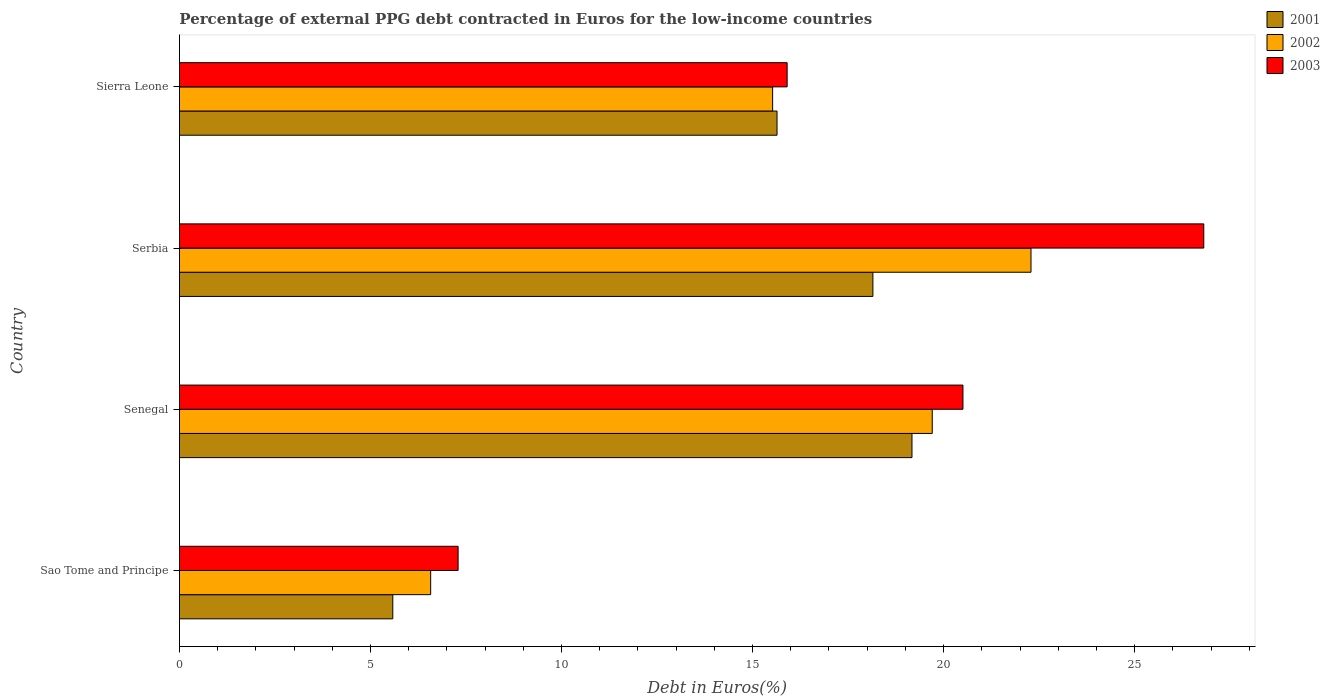How many groups of bars are there?
Give a very brief answer. 4. Are the number of bars on each tick of the Y-axis equal?
Make the answer very short. Yes. How many bars are there on the 2nd tick from the top?
Provide a short and direct response. 3. What is the label of the 2nd group of bars from the top?
Provide a short and direct response. Serbia. What is the percentage of external PPG debt contracted in Euros in 2001 in Senegal?
Your answer should be very brief. 19.17. Across all countries, what is the maximum percentage of external PPG debt contracted in Euros in 2001?
Provide a succinct answer. 19.17. Across all countries, what is the minimum percentage of external PPG debt contracted in Euros in 2001?
Offer a terse response. 5.58. In which country was the percentage of external PPG debt contracted in Euros in 2001 maximum?
Provide a short and direct response. Senegal. In which country was the percentage of external PPG debt contracted in Euros in 2003 minimum?
Provide a succinct answer. Sao Tome and Principe. What is the total percentage of external PPG debt contracted in Euros in 2001 in the graph?
Offer a very short reply. 58.55. What is the difference between the percentage of external PPG debt contracted in Euros in 2001 in Senegal and that in Serbia?
Your answer should be very brief. 1.02. What is the difference between the percentage of external PPG debt contracted in Euros in 2001 in Sierra Leone and the percentage of external PPG debt contracted in Euros in 2003 in Serbia?
Your response must be concise. -11.17. What is the average percentage of external PPG debt contracted in Euros in 2003 per country?
Provide a succinct answer. 17.63. What is the difference between the percentage of external PPG debt contracted in Euros in 2003 and percentage of external PPG debt contracted in Euros in 2001 in Sierra Leone?
Keep it short and to the point. 0.26. What is the ratio of the percentage of external PPG debt contracted in Euros in 2001 in Sao Tome and Principe to that in Serbia?
Your answer should be compact. 0.31. Is the percentage of external PPG debt contracted in Euros in 2002 in Sao Tome and Principe less than that in Serbia?
Keep it short and to the point. Yes. What is the difference between the highest and the second highest percentage of external PPG debt contracted in Euros in 2003?
Make the answer very short. 6.3. What is the difference between the highest and the lowest percentage of external PPG debt contracted in Euros in 2002?
Offer a terse response. 15.71. In how many countries, is the percentage of external PPG debt contracted in Euros in 2002 greater than the average percentage of external PPG debt contracted in Euros in 2002 taken over all countries?
Your answer should be compact. 2. Is the sum of the percentage of external PPG debt contracted in Euros in 2003 in Sao Tome and Principe and Serbia greater than the maximum percentage of external PPG debt contracted in Euros in 2002 across all countries?
Keep it short and to the point. Yes. What does the 2nd bar from the bottom in Sierra Leone represents?
Ensure brevity in your answer.  2002. Is it the case that in every country, the sum of the percentage of external PPG debt contracted in Euros in 2001 and percentage of external PPG debt contracted in Euros in 2002 is greater than the percentage of external PPG debt contracted in Euros in 2003?
Provide a succinct answer. Yes. Are all the bars in the graph horizontal?
Offer a very short reply. Yes. How many countries are there in the graph?
Make the answer very short. 4. What is the difference between two consecutive major ticks on the X-axis?
Offer a terse response. 5. Are the values on the major ticks of X-axis written in scientific E-notation?
Offer a very short reply. No. Does the graph contain any zero values?
Offer a very short reply. No. Does the graph contain grids?
Give a very brief answer. No. How many legend labels are there?
Provide a succinct answer. 3. What is the title of the graph?
Keep it short and to the point. Percentage of external PPG debt contracted in Euros for the low-income countries. What is the label or title of the X-axis?
Keep it short and to the point. Debt in Euros(%). What is the label or title of the Y-axis?
Ensure brevity in your answer.  Country. What is the Debt in Euros(%) of 2001 in Sao Tome and Principe?
Keep it short and to the point. 5.58. What is the Debt in Euros(%) in 2002 in Sao Tome and Principe?
Your answer should be very brief. 6.58. What is the Debt in Euros(%) in 2003 in Sao Tome and Principe?
Make the answer very short. 7.29. What is the Debt in Euros(%) of 2001 in Senegal?
Give a very brief answer. 19.17. What is the Debt in Euros(%) in 2002 in Senegal?
Provide a succinct answer. 19.7. What is the Debt in Euros(%) in 2003 in Senegal?
Your answer should be very brief. 20.51. What is the Debt in Euros(%) in 2001 in Serbia?
Make the answer very short. 18.15. What is the Debt in Euros(%) of 2002 in Serbia?
Ensure brevity in your answer.  22.29. What is the Debt in Euros(%) of 2003 in Serbia?
Your answer should be compact. 26.81. What is the Debt in Euros(%) of 2001 in Sierra Leone?
Provide a succinct answer. 15.64. What is the Debt in Euros(%) of 2002 in Sierra Leone?
Provide a succinct answer. 15.53. What is the Debt in Euros(%) in 2003 in Sierra Leone?
Keep it short and to the point. 15.91. Across all countries, what is the maximum Debt in Euros(%) of 2001?
Your answer should be very brief. 19.17. Across all countries, what is the maximum Debt in Euros(%) of 2002?
Provide a short and direct response. 22.29. Across all countries, what is the maximum Debt in Euros(%) of 2003?
Offer a terse response. 26.81. Across all countries, what is the minimum Debt in Euros(%) of 2001?
Make the answer very short. 5.58. Across all countries, what is the minimum Debt in Euros(%) of 2002?
Ensure brevity in your answer.  6.58. Across all countries, what is the minimum Debt in Euros(%) of 2003?
Provide a succinct answer. 7.29. What is the total Debt in Euros(%) in 2001 in the graph?
Give a very brief answer. 58.55. What is the total Debt in Euros(%) of 2002 in the graph?
Your answer should be very brief. 64.09. What is the total Debt in Euros(%) of 2003 in the graph?
Offer a terse response. 70.51. What is the difference between the Debt in Euros(%) in 2001 in Sao Tome and Principe and that in Senegal?
Make the answer very short. -13.59. What is the difference between the Debt in Euros(%) of 2002 in Sao Tome and Principe and that in Senegal?
Offer a terse response. -13.13. What is the difference between the Debt in Euros(%) in 2003 in Sao Tome and Principe and that in Senegal?
Your answer should be compact. -13.21. What is the difference between the Debt in Euros(%) in 2001 in Sao Tome and Principe and that in Serbia?
Offer a terse response. -12.57. What is the difference between the Debt in Euros(%) of 2002 in Sao Tome and Principe and that in Serbia?
Provide a succinct answer. -15.71. What is the difference between the Debt in Euros(%) in 2003 in Sao Tome and Principe and that in Serbia?
Provide a short and direct response. -19.52. What is the difference between the Debt in Euros(%) of 2001 in Sao Tome and Principe and that in Sierra Leone?
Your response must be concise. -10.06. What is the difference between the Debt in Euros(%) in 2002 in Sao Tome and Principe and that in Sierra Leone?
Offer a terse response. -8.95. What is the difference between the Debt in Euros(%) of 2003 in Sao Tome and Principe and that in Sierra Leone?
Give a very brief answer. -8.61. What is the difference between the Debt in Euros(%) in 2001 in Senegal and that in Serbia?
Your answer should be compact. 1.02. What is the difference between the Debt in Euros(%) of 2002 in Senegal and that in Serbia?
Offer a very short reply. -2.58. What is the difference between the Debt in Euros(%) in 2003 in Senegal and that in Serbia?
Offer a terse response. -6.3. What is the difference between the Debt in Euros(%) in 2001 in Senegal and that in Sierra Leone?
Ensure brevity in your answer.  3.53. What is the difference between the Debt in Euros(%) of 2002 in Senegal and that in Sierra Leone?
Your response must be concise. 4.18. What is the difference between the Debt in Euros(%) of 2003 in Senegal and that in Sierra Leone?
Provide a short and direct response. 4.6. What is the difference between the Debt in Euros(%) of 2001 in Serbia and that in Sierra Leone?
Ensure brevity in your answer.  2.51. What is the difference between the Debt in Euros(%) in 2002 in Serbia and that in Sierra Leone?
Offer a terse response. 6.76. What is the difference between the Debt in Euros(%) of 2003 in Serbia and that in Sierra Leone?
Keep it short and to the point. 10.9. What is the difference between the Debt in Euros(%) of 2001 in Sao Tome and Principe and the Debt in Euros(%) of 2002 in Senegal?
Provide a succinct answer. -14.12. What is the difference between the Debt in Euros(%) of 2001 in Sao Tome and Principe and the Debt in Euros(%) of 2003 in Senegal?
Provide a short and direct response. -14.92. What is the difference between the Debt in Euros(%) in 2002 in Sao Tome and Principe and the Debt in Euros(%) in 2003 in Senegal?
Give a very brief answer. -13.93. What is the difference between the Debt in Euros(%) in 2001 in Sao Tome and Principe and the Debt in Euros(%) in 2002 in Serbia?
Keep it short and to the point. -16.7. What is the difference between the Debt in Euros(%) in 2001 in Sao Tome and Principe and the Debt in Euros(%) in 2003 in Serbia?
Offer a terse response. -21.22. What is the difference between the Debt in Euros(%) in 2002 in Sao Tome and Principe and the Debt in Euros(%) in 2003 in Serbia?
Provide a short and direct response. -20.23. What is the difference between the Debt in Euros(%) in 2001 in Sao Tome and Principe and the Debt in Euros(%) in 2002 in Sierra Leone?
Your answer should be compact. -9.94. What is the difference between the Debt in Euros(%) in 2001 in Sao Tome and Principe and the Debt in Euros(%) in 2003 in Sierra Leone?
Provide a short and direct response. -10.32. What is the difference between the Debt in Euros(%) of 2002 in Sao Tome and Principe and the Debt in Euros(%) of 2003 in Sierra Leone?
Provide a succinct answer. -9.33. What is the difference between the Debt in Euros(%) in 2001 in Senegal and the Debt in Euros(%) in 2002 in Serbia?
Offer a terse response. -3.11. What is the difference between the Debt in Euros(%) of 2001 in Senegal and the Debt in Euros(%) of 2003 in Serbia?
Provide a short and direct response. -7.64. What is the difference between the Debt in Euros(%) of 2002 in Senegal and the Debt in Euros(%) of 2003 in Serbia?
Offer a terse response. -7.11. What is the difference between the Debt in Euros(%) of 2001 in Senegal and the Debt in Euros(%) of 2002 in Sierra Leone?
Ensure brevity in your answer.  3.65. What is the difference between the Debt in Euros(%) of 2001 in Senegal and the Debt in Euros(%) of 2003 in Sierra Leone?
Keep it short and to the point. 3.27. What is the difference between the Debt in Euros(%) in 2002 in Senegal and the Debt in Euros(%) in 2003 in Sierra Leone?
Your answer should be very brief. 3.8. What is the difference between the Debt in Euros(%) in 2001 in Serbia and the Debt in Euros(%) in 2002 in Sierra Leone?
Offer a terse response. 2.62. What is the difference between the Debt in Euros(%) of 2001 in Serbia and the Debt in Euros(%) of 2003 in Sierra Leone?
Ensure brevity in your answer.  2.24. What is the difference between the Debt in Euros(%) of 2002 in Serbia and the Debt in Euros(%) of 2003 in Sierra Leone?
Your answer should be very brief. 6.38. What is the average Debt in Euros(%) in 2001 per country?
Make the answer very short. 14.64. What is the average Debt in Euros(%) of 2002 per country?
Make the answer very short. 16.02. What is the average Debt in Euros(%) in 2003 per country?
Offer a terse response. 17.63. What is the difference between the Debt in Euros(%) in 2001 and Debt in Euros(%) in 2002 in Sao Tome and Principe?
Give a very brief answer. -0.99. What is the difference between the Debt in Euros(%) of 2001 and Debt in Euros(%) of 2003 in Sao Tome and Principe?
Provide a short and direct response. -1.71. What is the difference between the Debt in Euros(%) in 2002 and Debt in Euros(%) in 2003 in Sao Tome and Principe?
Offer a terse response. -0.72. What is the difference between the Debt in Euros(%) in 2001 and Debt in Euros(%) in 2002 in Senegal?
Your answer should be very brief. -0.53. What is the difference between the Debt in Euros(%) of 2001 and Debt in Euros(%) of 2003 in Senegal?
Provide a short and direct response. -1.33. What is the difference between the Debt in Euros(%) of 2002 and Debt in Euros(%) of 2003 in Senegal?
Ensure brevity in your answer.  -0.8. What is the difference between the Debt in Euros(%) in 2001 and Debt in Euros(%) in 2002 in Serbia?
Your response must be concise. -4.14. What is the difference between the Debt in Euros(%) of 2001 and Debt in Euros(%) of 2003 in Serbia?
Provide a short and direct response. -8.66. What is the difference between the Debt in Euros(%) of 2002 and Debt in Euros(%) of 2003 in Serbia?
Make the answer very short. -4.52. What is the difference between the Debt in Euros(%) of 2001 and Debt in Euros(%) of 2002 in Sierra Leone?
Make the answer very short. 0.12. What is the difference between the Debt in Euros(%) in 2001 and Debt in Euros(%) in 2003 in Sierra Leone?
Offer a terse response. -0.26. What is the difference between the Debt in Euros(%) in 2002 and Debt in Euros(%) in 2003 in Sierra Leone?
Keep it short and to the point. -0.38. What is the ratio of the Debt in Euros(%) in 2001 in Sao Tome and Principe to that in Senegal?
Ensure brevity in your answer.  0.29. What is the ratio of the Debt in Euros(%) in 2002 in Sao Tome and Principe to that in Senegal?
Give a very brief answer. 0.33. What is the ratio of the Debt in Euros(%) in 2003 in Sao Tome and Principe to that in Senegal?
Keep it short and to the point. 0.36. What is the ratio of the Debt in Euros(%) of 2001 in Sao Tome and Principe to that in Serbia?
Provide a short and direct response. 0.31. What is the ratio of the Debt in Euros(%) of 2002 in Sao Tome and Principe to that in Serbia?
Ensure brevity in your answer.  0.3. What is the ratio of the Debt in Euros(%) in 2003 in Sao Tome and Principe to that in Serbia?
Offer a terse response. 0.27. What is the ratio of the Debt in Euros(%) in 2001 in Sao Tome and Principe to that in Sierra Leone?
Give a very brief answer. 0.36. What is the ratio of the Debt in Euros(%) of 2002 in Sao Tome and Principe to that in Sierra Leone?
Provide a short and direct response. 0.42. What is the ratio of the Debt in Euros(%) of 2003 in Sao Tome and Principe to that in Sierra Leone?
Ensure brevity in your answer.  0.46. What is the ratio of the Debt in Euros(%) in 2001 in Senegal to that in Serbia?
Make the answer very short. 1.06. What is the ratio of the Debt in Euros(%) in 2002 in Senegal to that in Serbia?
Your answer should be compact. 0.88. What is the ratio of the Debt in Euros(%) of 2003 in Senegal to that in Serbia?
Keep it short and to the point. 0.76. What is the ratio of the Debt in Euros(%) of 2001 in Senegal to that in Sierra Leone?
Offer a terse response. 1.23. What is the ratio of the Debt in Euros(%) of 2002 in Senegal to that in Sierra Leone?
Keep it short and to the point. 1.27. What is the ratio of the Debt in Euros(%) in 2003 in Senegal to that in Sierra Leone?
Ensure brevity in your answer.  1.29. What is the ratio of the Debt in Euros(%) in 2001 in Serbia to that in Sierra Leone?
Keep it short and to the point. 1.16. What is the ratio of the Debt in Euros(%) in 2002 in Serbia to that in Sierra Leone?
Your answer should be compact. 1.44. What is the ratio of the Debt in Euros(%) of 2003 in Serbia to that in Sierra Leone?
Keep it short and to the point. 1.69. What is the difference between the highest and the second highest Debt in Euros(%) of 2001?
Keep it short and to the point. 1.02. What is the difference between the highest and the second highest Debt in Euros(%) in 2002?
Your answer should be compact. 2.58. What is the difference between the highest and the second highest Debt in Euros(%) in 2003?
Offer a very short reply. 6.3. What is the difference between the highest and the lowest Debt in Euros(%) in 2001?
Offer a terse response. 13.59. What is the difference between the highest and the lowest Debt in Euros(%) in 2002?
Your answer should be compact. 15.71. What is the difference between the highest and the lowest Debt in Euros(%) in 2003?
Your answer should be compact. 19.52. 